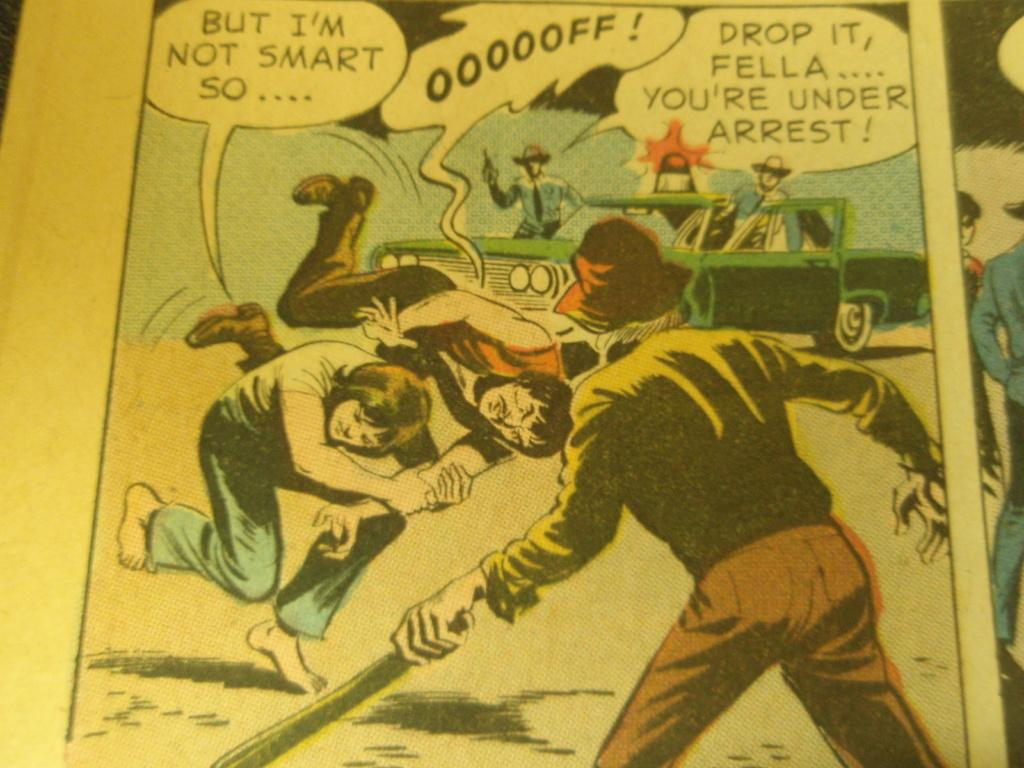What type of image is being described? The image is a comic. Who or what can be seen in the comic? There are people and a car in the comic. Are there any words or phrases in the comic? Yes, there is edited text in the comic. What type of cakes are being served in the comic? There are no cakes present in the comic; it features people, a car, and edited text. How many pails are visible in the comic? There is no pail present in the comic. 